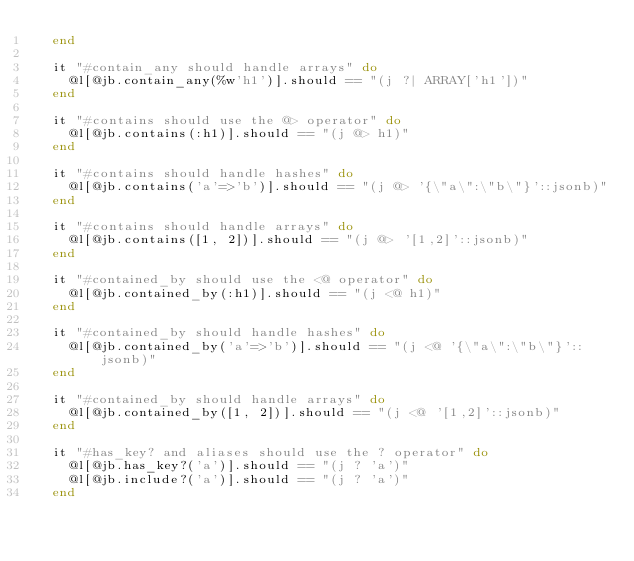Convert code to text. <code><loc_0><loc_0><loc_500><loc_500><_Ruby_>  end

  it "#contain_any should handle arrays" do
    @l[@jb.contain_any(%w'h1')].should == "(j ?| ARRAY['h1'])"
  end

  it "#contains should use the @> operator" do
    @l[@jb.contains(:h1)].should == "(j @> h1)"
  end

  it "#contains should handle hashes" do
    @l[@jb.contains('a'=>'b')].should == "(j @> '{\"a\":\"b\"}'::jsonb)"
  end

  it "#contains should handle arrays" do
    @l[@jb.contains([1, 2])].should == "(j @> '[1,2]'::jsonb)"
  end

  it "#contained_by should use the <@ operator" do
    @l[@jb.contained_by(:h1)].should == "(j <@ h1)"
  end

  it "#contained_by should handle hashes" do
    @l[@jb.contained_by('a'=>'b')].should == "(j <@ '{\"a\":\"b\"}'::jsonb)"
  end

  it "#contained_by should handle arrays" do
    @l[@jb.contained_by([1, 2])].should == "(j <@ '[1,2]'::jsonb)"
  end

  it "#has_key? and aliases should use the ? operator" do
    @l[@jb.has_key?('a')].should == "(j ? 'a')"
    @l[@jb.include?('a')].should == "(j ? 'a')"
  end
</code> 